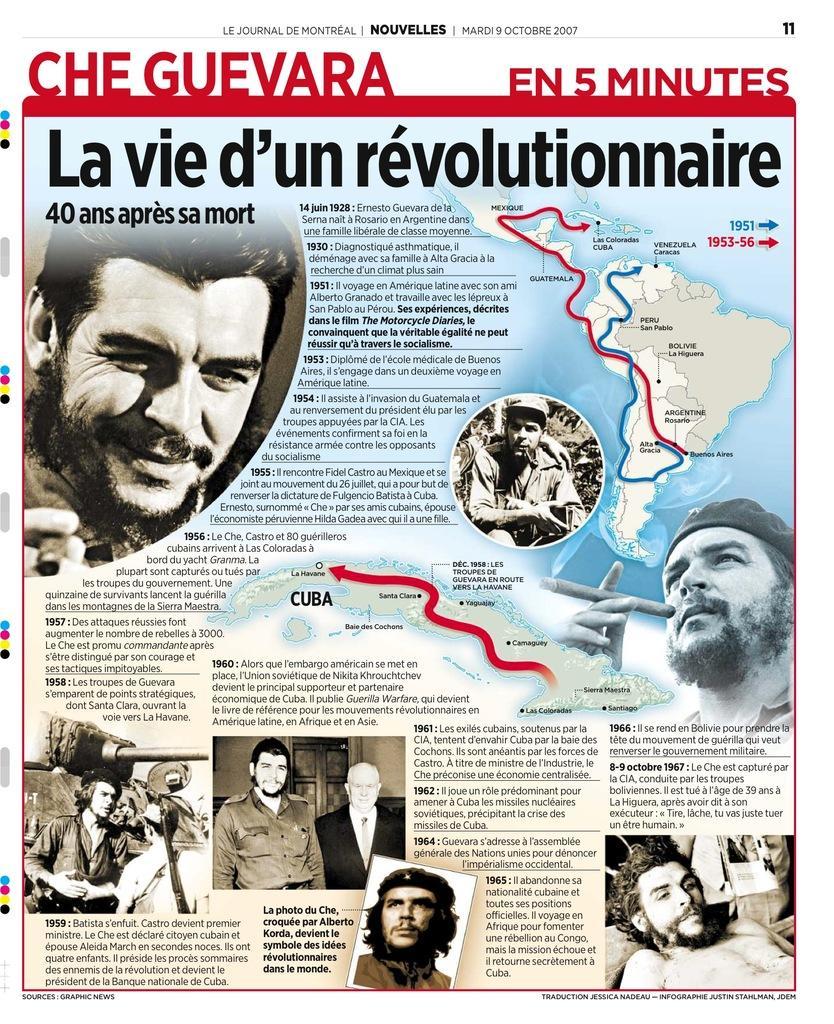How would you summarize this image in a sentence or two? This is the poster image in which there are text written on it and there are images of the persons. 